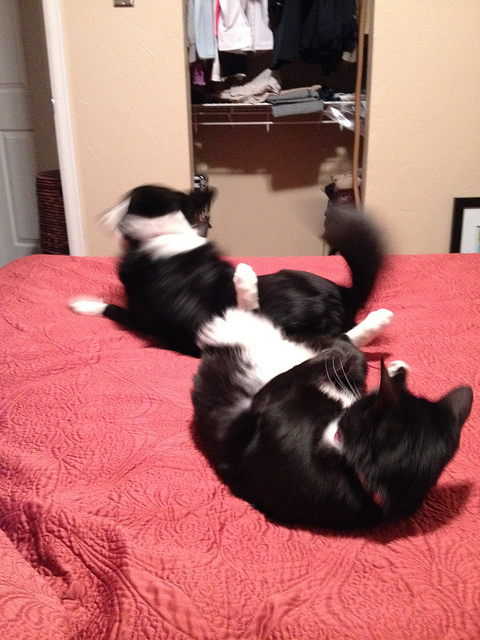Can you describe the room setting behind the cats? Certainly! Behind the energetic feline duo, we can glimpse into a room that includes a mirrored closet door. The mirror reflects a partially open closet filled with various clothing items. The room's ambiance is cozy and personal, indicating a lived-in space. The door is ajar, giving a sense of casualness to the surroundings. 